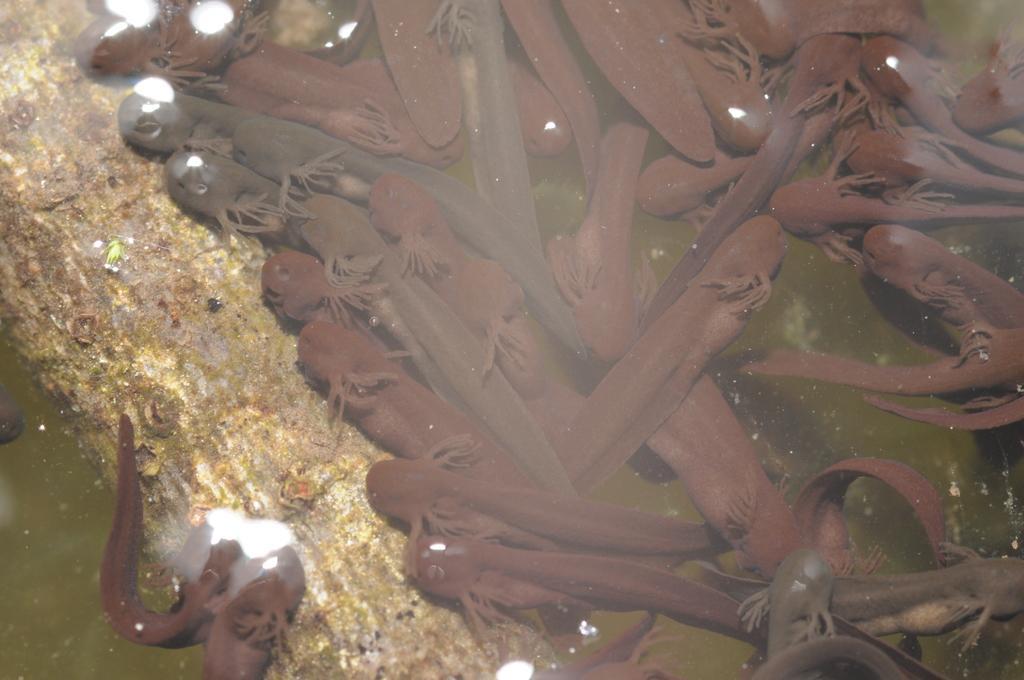Please provide a concise description of this image. In this image there are a few fishes and a wooden stem of a tree in the water. 